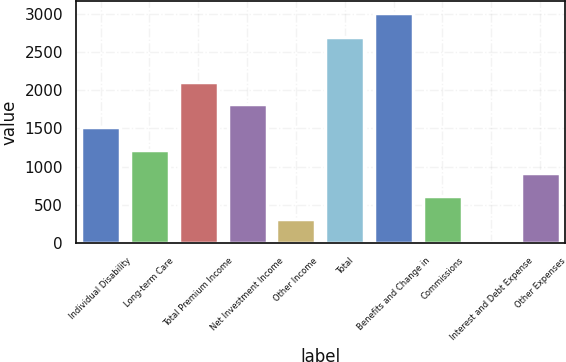Convert chart. <chart><loc_0><loc_0><loc_500><loc_500><bar_chart><fcel>Individual Disability<fcel>Long-term Care<fcel>Total Premium Income<fcel>Net Investment Income<fcel>Other Income<fcel>Total<fcel>Benefits and Change in<fcel>Commissions<fcel>Interest and Debt Expense<fcel>Other Expenses<nl><fcel>1511.65<fcel>1211.42<fcel>2112.11<fcel>1811.88<fcel>310.73<fcel>2691.1<fcel>3012.8<fcel>610.96<fcel>10.5<fcel>911.19<nl></chart> 